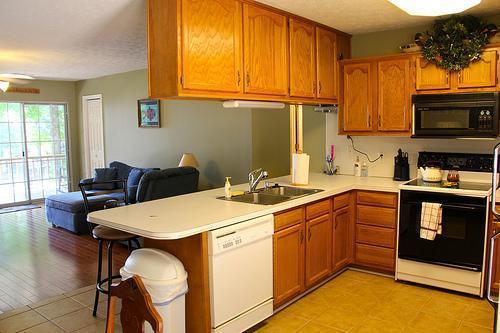How many ovens are there?
Give a very brief answer. 1. 